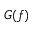Convert formula to latex. <formula><loc_0><loc_0><loc_500><loc_500>G ( f )</formula> 